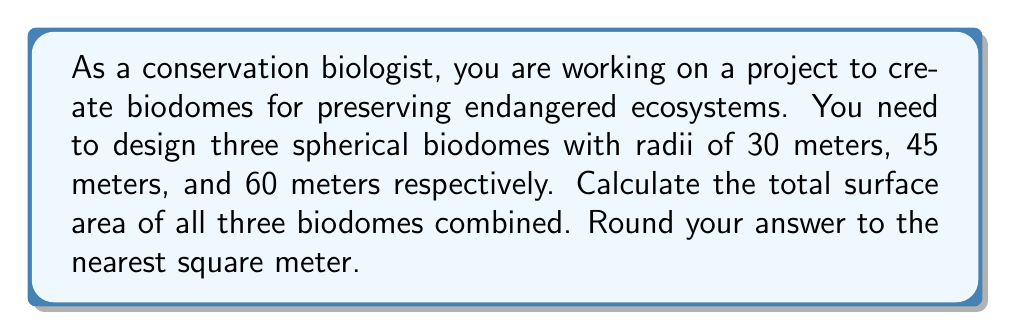Can you answer this question? To solve this problem, we need to follow these steps:

1. Recall the formula for the surface area of a sphere:
   $$ A = 4\pi r^2 $$
   where $A$ is the surface area and $r$ is the radius.

2. Calculate the surface area for each biodome:

   For the 30-meter radius biodome:
   $$ A_1 = 4\pi (30)^2 = 4\pi (900) = 3600\pi \approx 11,309.73 \text{ m}^2 $$

   For the 45-meter radius biodome:
   $$ A_2 = 4\pi (45)^2 = 4\pi (2025) = 8100\pi \approx 25,446.90 \text{ m}^2 $$

   For the 60-meter radius biodome:
   $$ A_3 = 4\pi (60)^2 = 4\pi (3600) = 14400\pi \approx 45,238.93 \text{ m}^2 $$

3. Sum up the surface areas of all three biodomes:
   $$ A_{total} = A_1 + A_2 + A_3 $$
   $$ A_{total} = 11,309.73 + 25,446.90 + 45,238.93 = 81,995.56 \text{ m}^2 $$

4. Round the result to the nearest square meter:
   $$ A_{total} \approx 81,996 \text{ m}^2 $$
Answer: The total surface area of all three biodomes combined is approximately 81,996 square meters. 